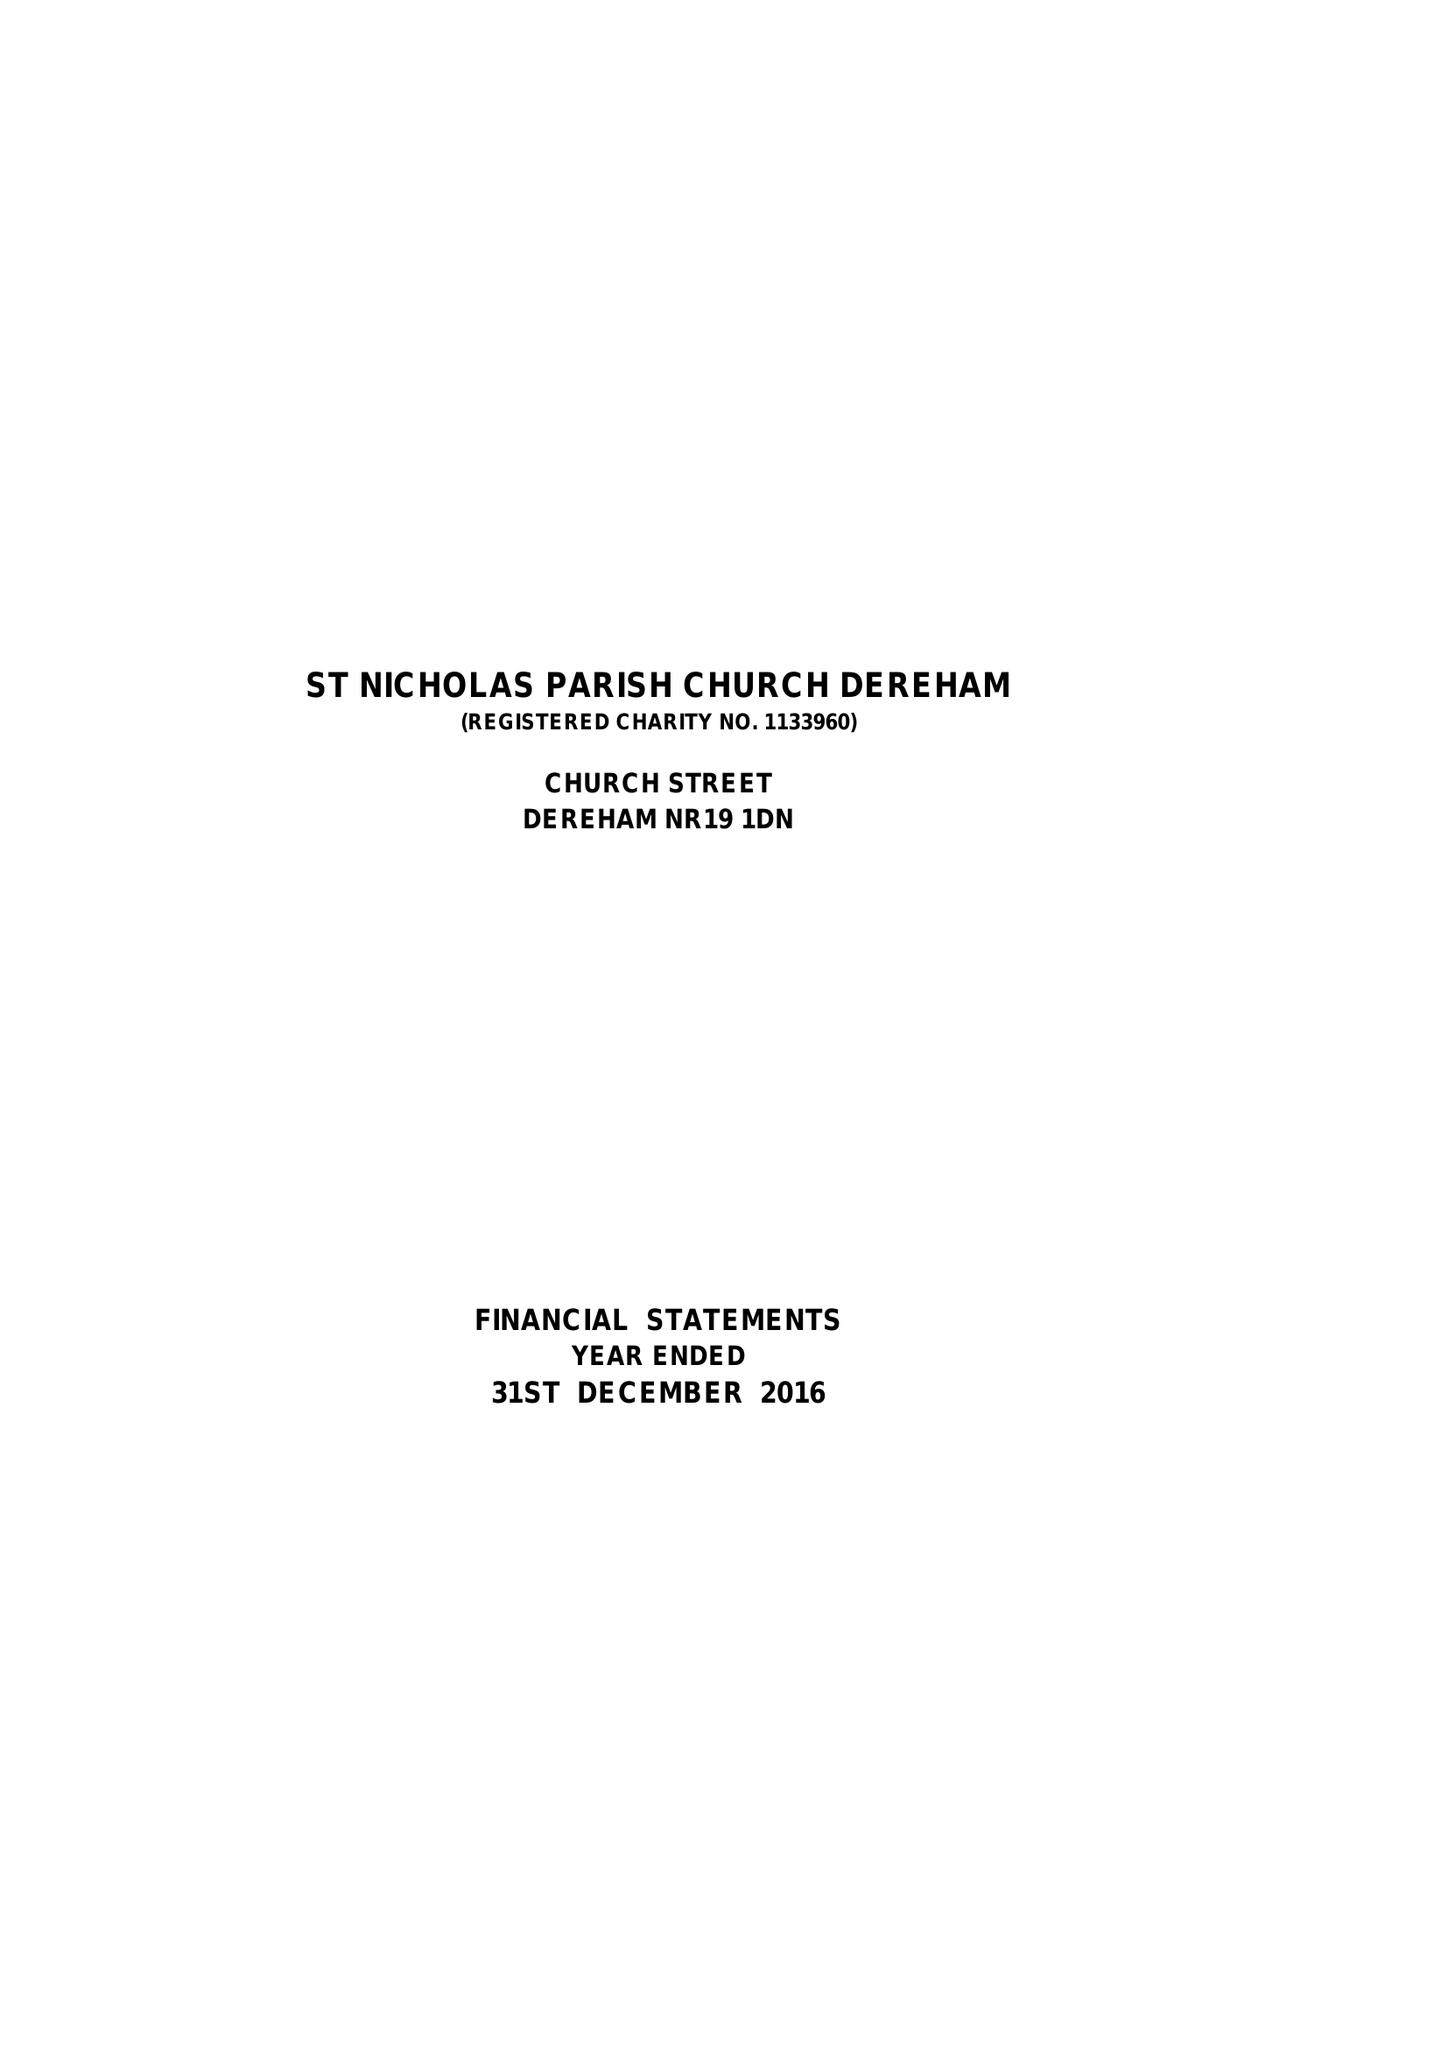What is the value for the address__street_line?
Answer the question using a single word or phrase. CHURCH STREET 